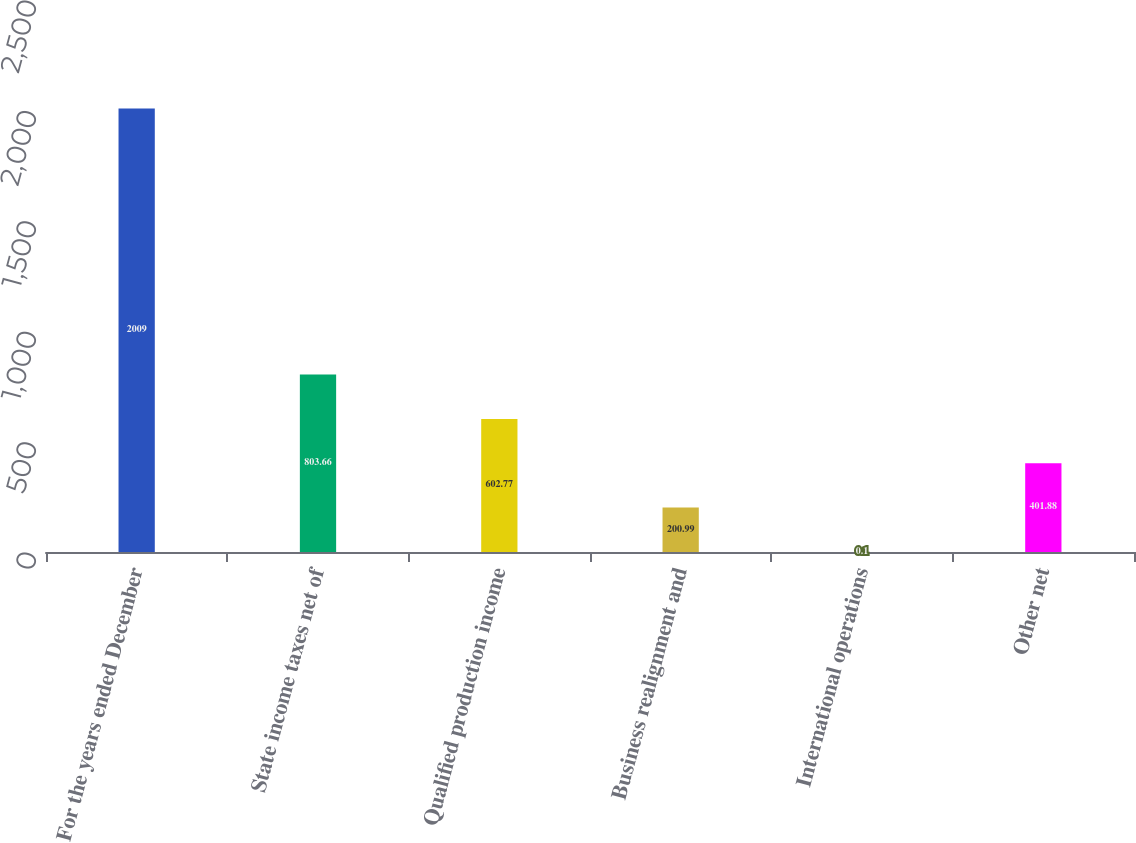Convert chart. <chart><loc_0><loc_0><loc_500><loc_500><bar_chart><fcel>For the years ended December<fcel>State income taxes net of<fcel>Qualified production income<fcel>Business realignment and<fcel>International operations<fcel>Other net<nl><fcel>2009<fcel>803.66<fcel>602.77<fcel>200.99<fcel>0.1<fcel>401.88<nl></chart> 